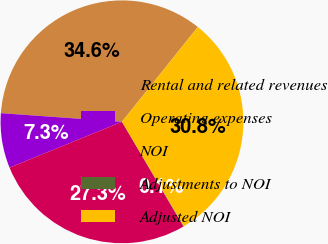Convert chart to OTSL. <chart><loc_0><loc_0><loc_500><loc_500><pie_chart><fcel>Rental and related revenues<fcel>Operating expenses<fcel>NOI<fcel>Adjustments to NOI<fcel>Adjusted NOI<nl><fcel>34.6%<fcel>7.3%<fcel>27.29%<fcel>0.06%<fcel>30.75%<nl></chart> 